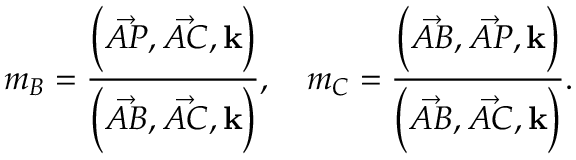Convert formula to latex. <formula><loc_0><loc_0><loc_500><loc_500>m _ { B } = { \frac { { \left ( } { \vec { A P } } , { \vec { A C } } , k { \right ) } } { { \left ( } { \vec { A B } } , { \vec { A C } } , k { \right ) } } } , \quad m _ { C } = { \frac { { \left ( } { \vec { A B } } , { \vec { A P } } , k { \right ) } } { { \left ( } { \vec { A B } } , { \vec { A C } } , k { \right ) } } } .</formula> 